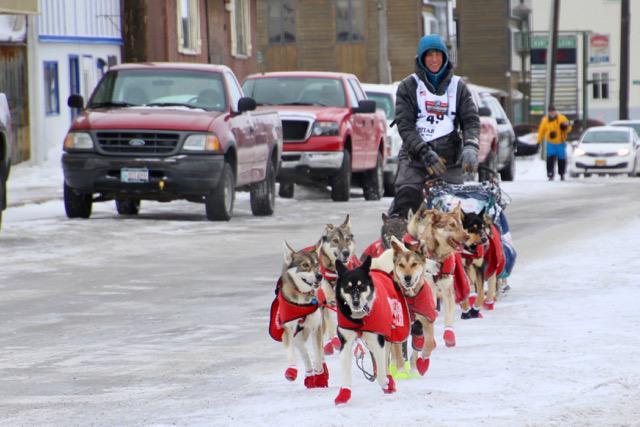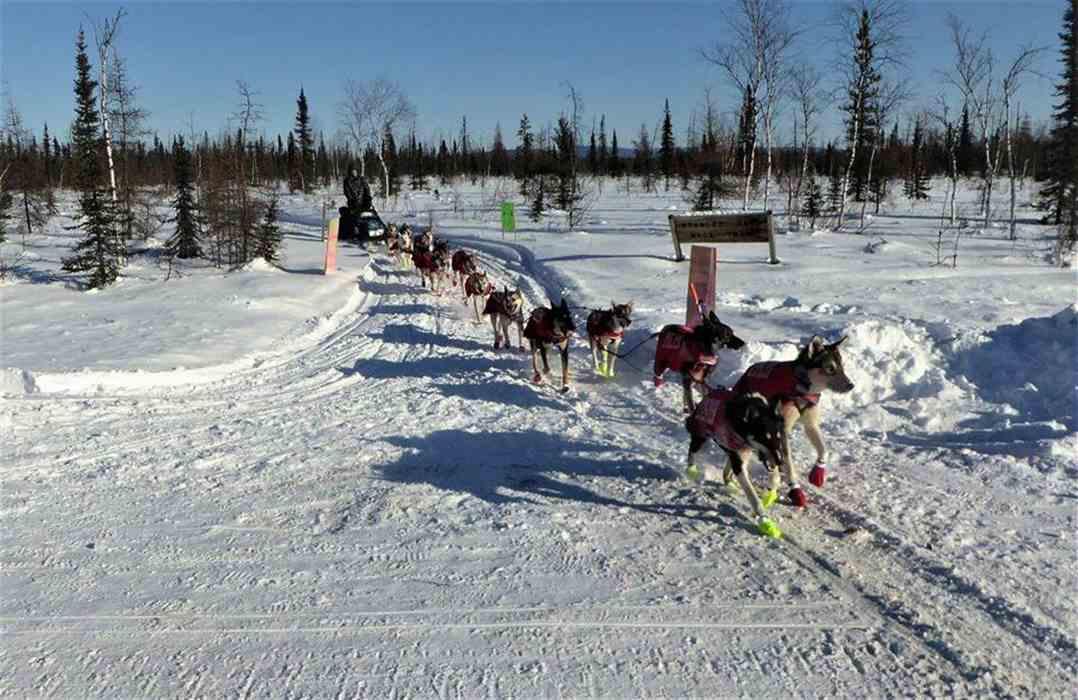The first image is the image on the left, the second image is the image on the right. Given the left and right images, does the statement "There is exactly one dog in the image on the right." hold true? Answer yes or no. No. The first image is the image on the left, the second image is the image on the right. Examine the images to the left and right. Is the description "A person is being pulled by a team of dogs in one image." accurate? Answer yes or no. Yes. 